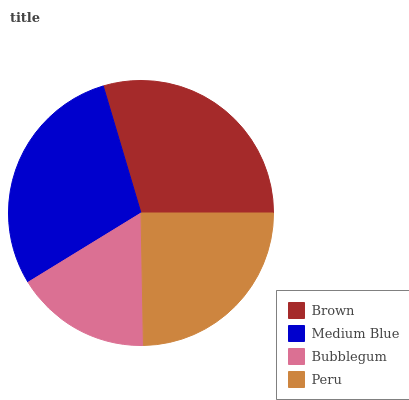Is Bubblegum the minimum?
Answer yes or no. Yes. Is Brown the maximum?
Answer yes or no. Yes. Is Medium Blue the minimum?
Answer yes or no. No. Is Medium Blue the maximum?
Answer yes or no. No. Is Brown greater than Medium Blue?
Answer yes or no. Yes. Is Medium Blue less than Brown?
Answer yes or no. Yes. Is Medium Blue greater than Brown?
Answer yes or no. No. Is Brown less than Medium Blue?
Answer yes or no. No. Is Medium Blue the high median?
Answer yes or no. Yes. Is Peru the low median?
Answer yes or no. Yes. Is Bubblegum the high median?
Answer yes or no. No. Is Bubblegum the low median?
Answer yes or no. No. 